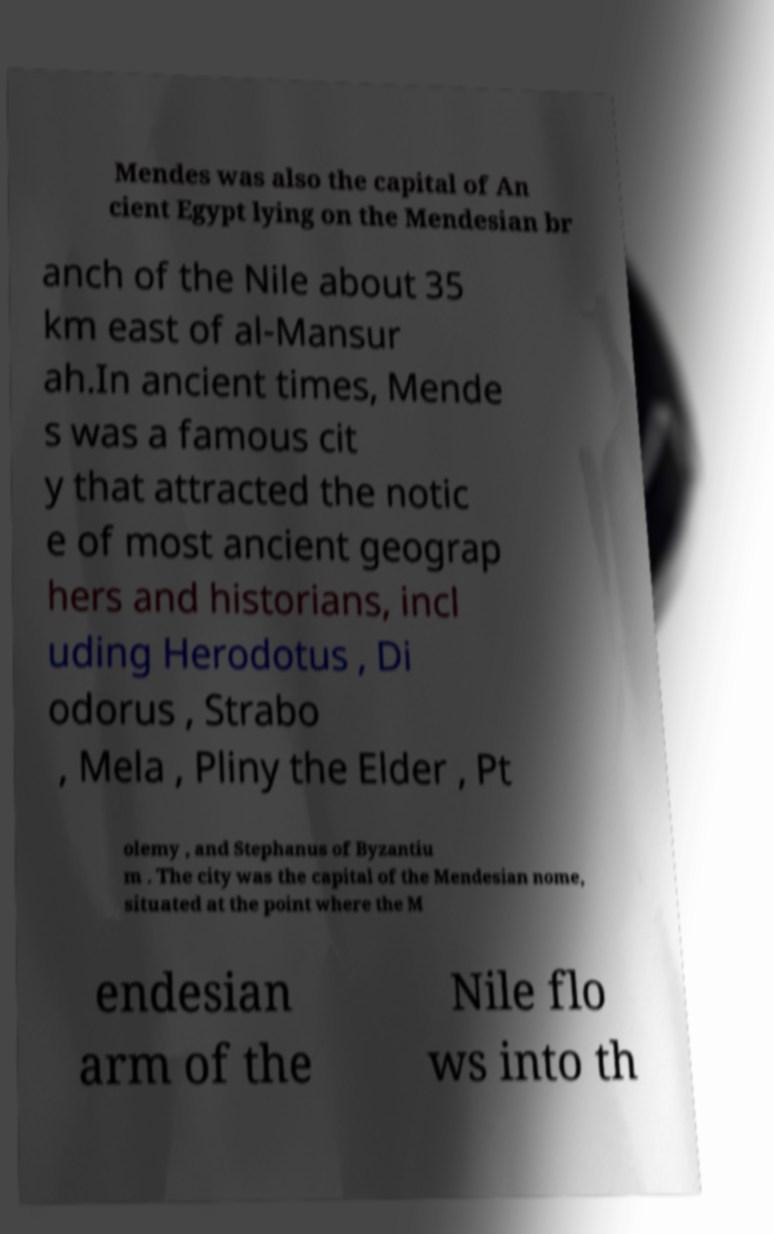Could you assist in decoding the text presented in this image and type it out clearly? Mendes was also the capital of An cient Egypt lying on the Mendesian br anch of the Nile about 35 km east of al-Mansur ah.In ancient times, Mende s was a famous cit y that attracted the notic e of most ancient geograp hers and historians, incl uding Herodotus , Di odorus , Strabo , Mela , Pliny the Elder , Pt olemy , and Stephanus of Byzantiu m . The city was the capital of the Mendesian nome, situated at the point where the M endesian arm of the Nile flo ws into th 